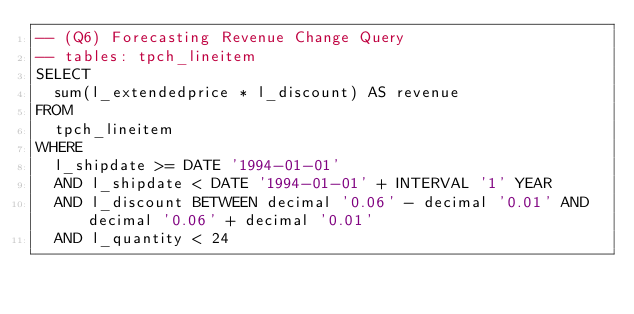Convert code to text. <code><loc_0><loc_0><loc_500><loc_500><_SQL_>-- (Q6) Forecasting Revenue Change Query
-- tables: tpch_lineitem
SELECT
  sum(l_extendedprice * l_discount) AS revenue
FROM
  tpch_lineitem
WHERE
  l_shipdate >= DATE '1994-01-01'
  AND l_shipdate < DATE '1994-01-01' + INTERVAL '1' YEAR
  AND l_discount BETWEEN decimal '0.06' - decimal '0.01' AND decimal '0.06' + decimal '0.01'
  AND l_quantity < 24</code> 